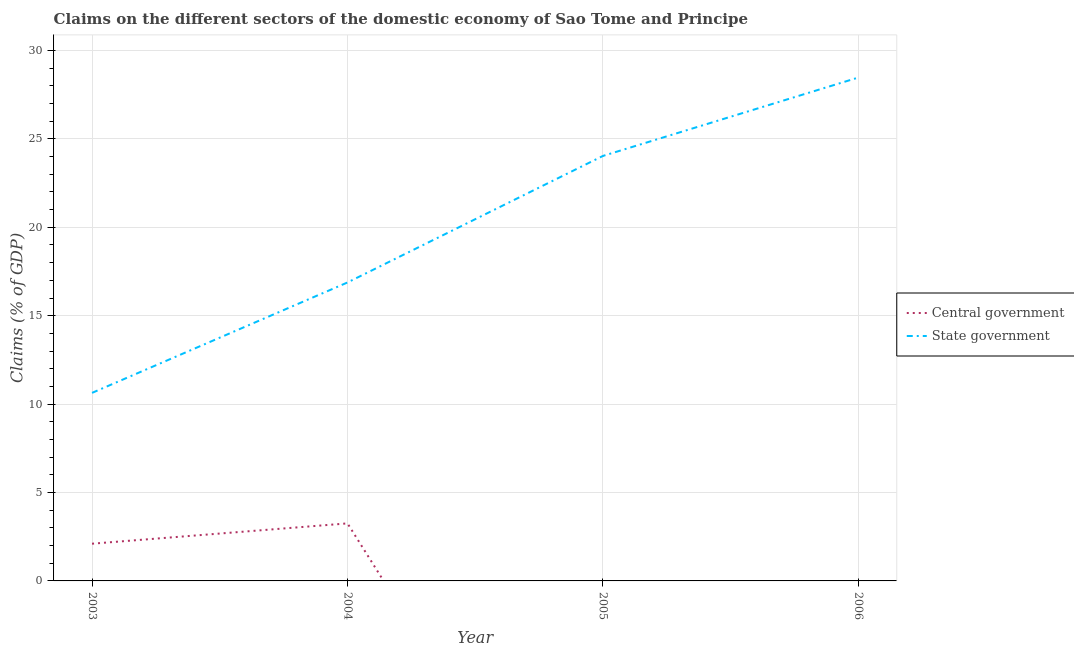What is the claims on state government in 2004?
Your answer should be very brief. 16.88. Across all years, what is the maximum claims on state government?
Your answer should be compact. 28.47. What is the total claims on central government in the graph?
Keep it short and to the point. 5.36. What is the difference between the claims on state government in 2003 and that in 2004?
Give a very brief answer. -6.24. What is the difference between the claims on state government in 2005 and the claims on central government in 2004?
Your answer should be compact. 20.78. What is the average claims on central government per year?
Keep it short and to the point. 1.34. In the year 2003, what is the difference between the claims on state government and claims on central government?
Your response must be concise. 8.53. In how many years, is the claims on central government greater than 16 %?
Your response must be concise. 0. What is the ratio of the claims on state government in 2003 to that in 2004?
Ensure brevity in your answer.  0.63. Is the claims on state government in 2005 less than that in 2006?
Your answer should be very brief. Yes. What is the difference between the highest and the second highest claims on state government?
Offer a terse response. 4.43. What is the difference between the highest and the lowest claims on central government?
Give a very brief answer. 3.25. In how many years, is the claims on state government greater than the average claims on state government taken over all years?
Your answer should be compact. 2. How many lines are there?
Your answer should be compact. 2. How many years are there in the graph?
Provide a short and direct response. 4. Does the graph contain any zero values?
Give a very brief answer. Yes. Where does the legend appear in the graph?
Offer a terse response. Center right. How are the legend labels stacked?
Offer a terse response. Vertical. What is the title of the graph?
Give a very brief answer. Claims on the different sectors of the domestic economy of Sao Tome and Principe. Does "Public funds" appear as one of the legend labels in the graph?
Your answer should be compact. No. What is the label or title of the Y-axis?
Provide a short and direct response. Claims (% of GDP). What is the Claims (% of GDP) of Central government in 2003?
Give a very brief answer. 2.1. What is the Claims (% of GDP) in State government in 2003?
Offer a terse response. 10.64. What is the Claims (% of GDP) in Central government in 2004?
Your answer should be compact. 3.25. What is the Claims (% of GDP) of State government in 2004?
Give a very brief answer. 16.88. What is the Claims (% of GDP) in Central government in 2005?
Your response must be concise. 0. What is the Claims (% of GDP) of State government in 2005?
Your answer should be compact. 24.04. What is the Claims (% of GDP) in Central government in 2006?
Your answer should be very brief. 0. What is the Claims (% of GDP) in State government in 2006?
Your response must be concise. 28.47. Across all years, what is the maximum Claims (% of GDP) of Central government?
Offer a very short reply. 3.25. Across all years, what is the maximum Claims (% of GDP) in State government?
Your answer should be compact. 28.47. Across all years, what is the minimum Claims (% of GDP) in State government?
Offer a terse response. 10.64. What is the total Claims (% of GDP) of Central government in the graph?
Your answer should be very brief. 5.36. What is the total Claims (% of GDP) of State government in the graph?
Give a very brief answer. 80.02. What is the difference between the Claims (% of GDP) in Central government in 2003 and that in 2004?
Provide a succinct answer. -1.15. What is the difference between the Claims (% of GDP) in State government in 2003 and that in 2004?
Keep it short and to the point. -6.24. What is the difference between the Claims (% of GDP) of State government in 2003 and that in 2005?
Your answer should be compact. -13.4. What is the difference between the Claims (% of GDP) of State government in 2003 and that in 2006?
Your answer should be very brief. -17.83. What is the difference between the Claims (% of GDP) in State government in 2004 and that in 2005?
Ensure brevity in your answer.  -7.16. What is the difference between the Claims (% of GDP) of State government in 2004 and that in 2006?
Give a very brief answer. -11.59. What is the difference between the Claims (% of GDP) in State government in 2005 and that in 2006?
Give a very brief answer. -4.43. What is the difference between the Claims (% of GDP) of Central government in 2003 and the Claims (% of GDP) of State government in 2004?
Offer a terse response. -14.77. What is the difference between the Claims (% of GDP) in Central government in 2003 and the Claims (% of GDP) in State government in 2005?
Your response must be concise. -21.93. What is the difference between the Claims (% of GDP) in Central government in 2003 and the Claims (% of GDP) in State government in 2006?
Provide a succinct answer. -26.36. What is the difference between the Claims (% of GDP) in Central government in 2004 and the Claims (% of GDP) in State government in 2005?
Your answer should be very brief. -20.78. What is the difference between the Claims (% of GDP) in Central government in 2004 and the Claims (% of GDP) in State government in 2006?
Provide a short and direct response. -25.22. What is the average Claims (% of GDP) in Central government per year?
Your response must be concise. 1.34. What is the average Claims (% of GDP) in State government per year?
Make the answer very short. 20. In the year 2003, what is the difference between the Claims (% of GDP) of Central government and Claims (% of GDP) of State government?
Ensure brevity in your answer.  -8.53. In the year 2004, what is the difference between the Claims (% of GDP) in Central government and Claims (% of GDP) in State government?
Provide a succinct answer. -13.63. What is the ratio of the Claims (% of GDP) of Central government in 2003 to that in 2004?
Ensure brevity in your answer.  0.65. What is the ratio of the Claims (% of GDP) in State government in 2003 to that in 2004?
Keep it short and to the point. 0.63. What is the ratio of the Claims (% of GDP) of State government in 2003 to that in 2005?
Ensure brevity in your answer.  0.44. What is the ratio of the Claims (% of GDP) of State government in 2003 to that in 2006?
Provide a short and direct response. 0.37. What is the ratio of the Claims (% of GDP) of State government in 2004 to that in 2005?
Ensure brevity in your answer.  0.7. What is the ratio of the Claims (% of GDP) in State government in 2004 to that in 2006?
Keep it short and to the point. 0.59. What is the ratio of the Claims (% of GDP) of State government in 2005 to that in 2006?
Make the answer very short. 0.84. What is the difference between the highest and the second highest Claims (% of GDP) of State government?
Give a very brief answer. 4.43. What is the difference between the highest and the lowest Claims (% of GDP) of Central government?
Your answer should be very brief. 3.25. What is the difference between the highest and the lowest Claims (% of GDP) in State government?
Offer a very short reply. 17.83. 